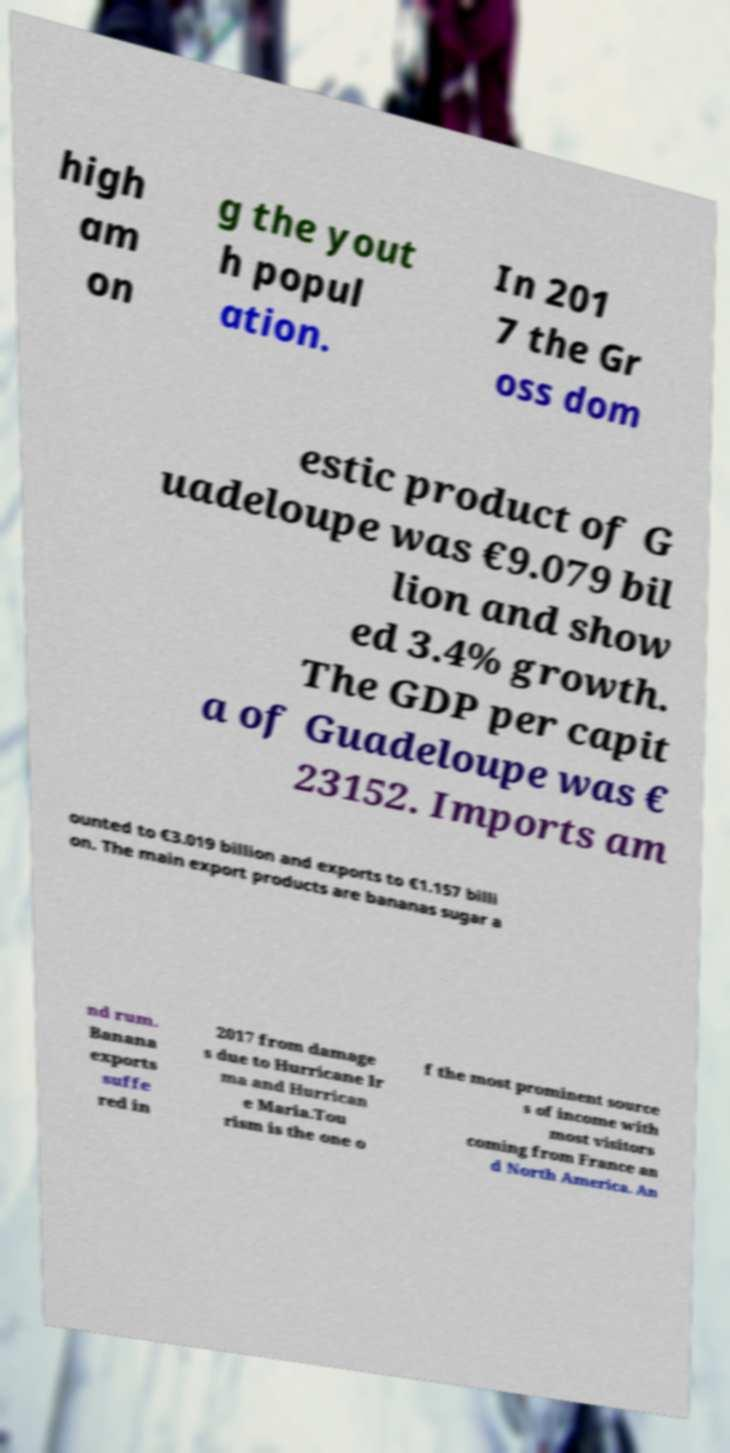For documentation purposes, I need the text within this image transcribed. Could you provide that? high am on g the yout h popul ation. In 201 7 the Gr oss dom estic product of G uadeloupe was €9.079 bil lion and show ed 3.4% growth. The GDP per capit a of Guadeloupe was € 23152. Imports am ounted to €3.019 billion and exports to €1.157 billi on. The main export products are bananas sugar a nd rum. Banana exports suffe red in 2017 from damage s due to Hurricane Ir ma and Hurrican e Maria.Tou rism is the one o f the most prominent source s of income with most visitors coming from France an d North America. An 